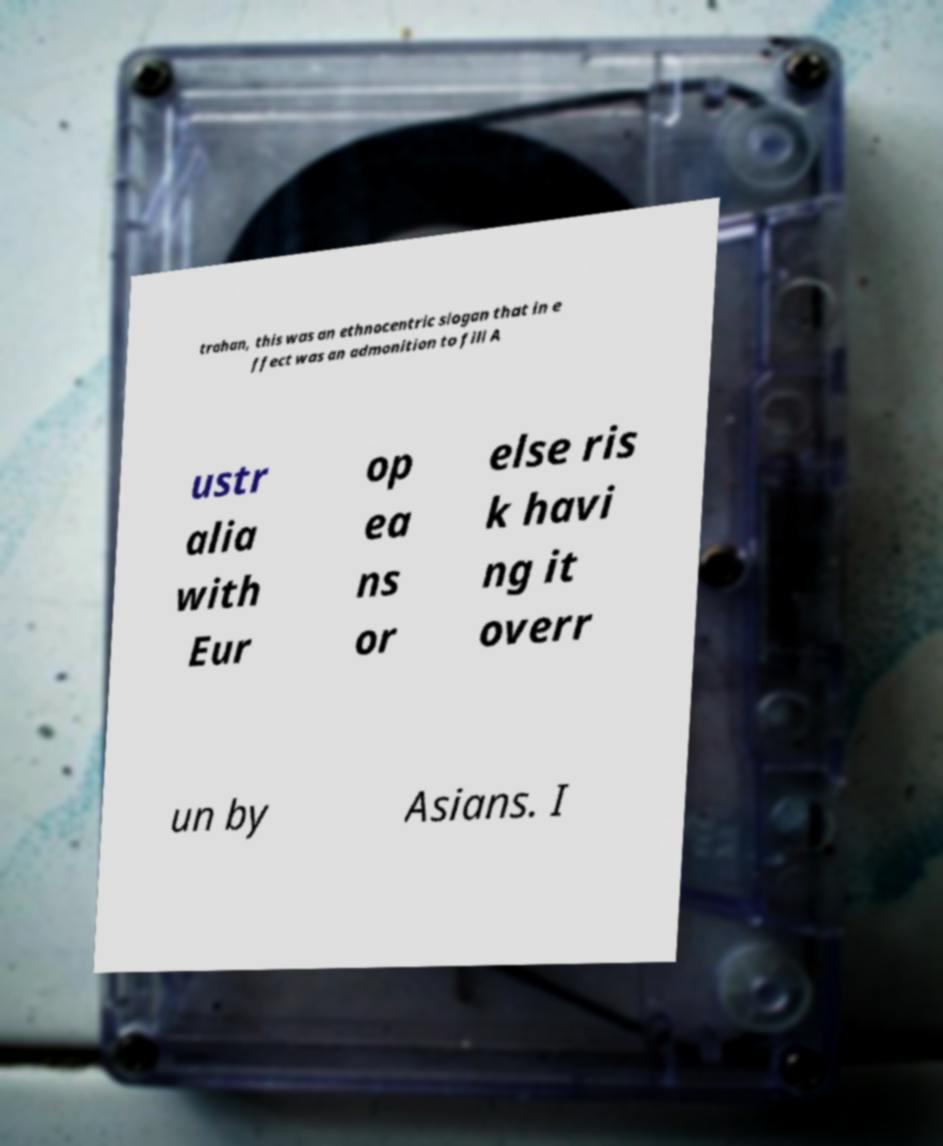For documentation purposes, I need the text within this image transcribed. Could you provide that? trahan, this was an ethnocentric slogan that in e ffect was an admonition to fill A ustr alia with Eur op ea ns or else ris k havi ng it overr un by Asians. I 